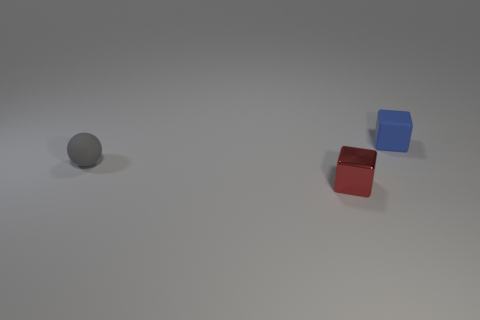Add 2 small cyan rubber cylinders. How many objects exist? 5 Subtract all large green cubes. Subtract all small matte balls. How many objects are left? 2 Add 2 small things. How many small things are left? 5 Add 1 spheres. How many spheres exist? 2 Subtract 0 purple cylinders. How many objects are left? 3 Subtract all cubes. How many objects are left? 1 